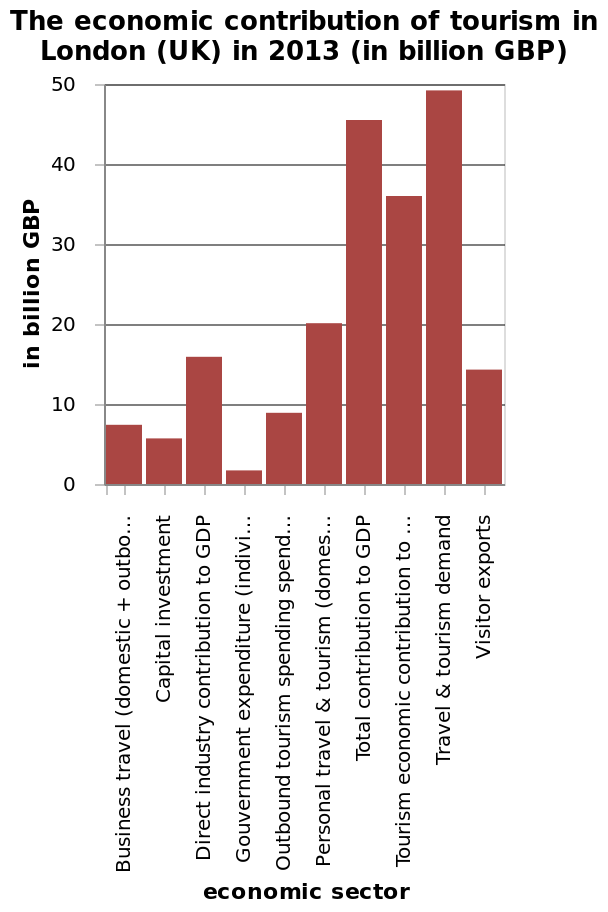<image>
How much did the lowest contributing sector contribute in 2013?  The lowest contributing sector in 2013 contributed an unspecified amount. How much did the majority of sectors contribute in 2013? The majority of sectors contributed less than £20 billion in 2013. What is the economic sector labeled on the x-axis in the bar diagram?  The economic sector labeled on the x-axis in the bar diagram is Business travel (domestic + outbound). What is the highest economic sector on the x-axis in the bar diagram? The highest economic sector on the x-axis in the bar diagram is [missing information]. What was the biggest contributing sector to the UK economy in 2013?  The biggest contributing sector to the UK economy in 2013 was Travel & Tourism demand. Which sector had the highest contribution among all the sectors in 2013? The Travel & Tourism demand sector had the highest contribution in 2013. 